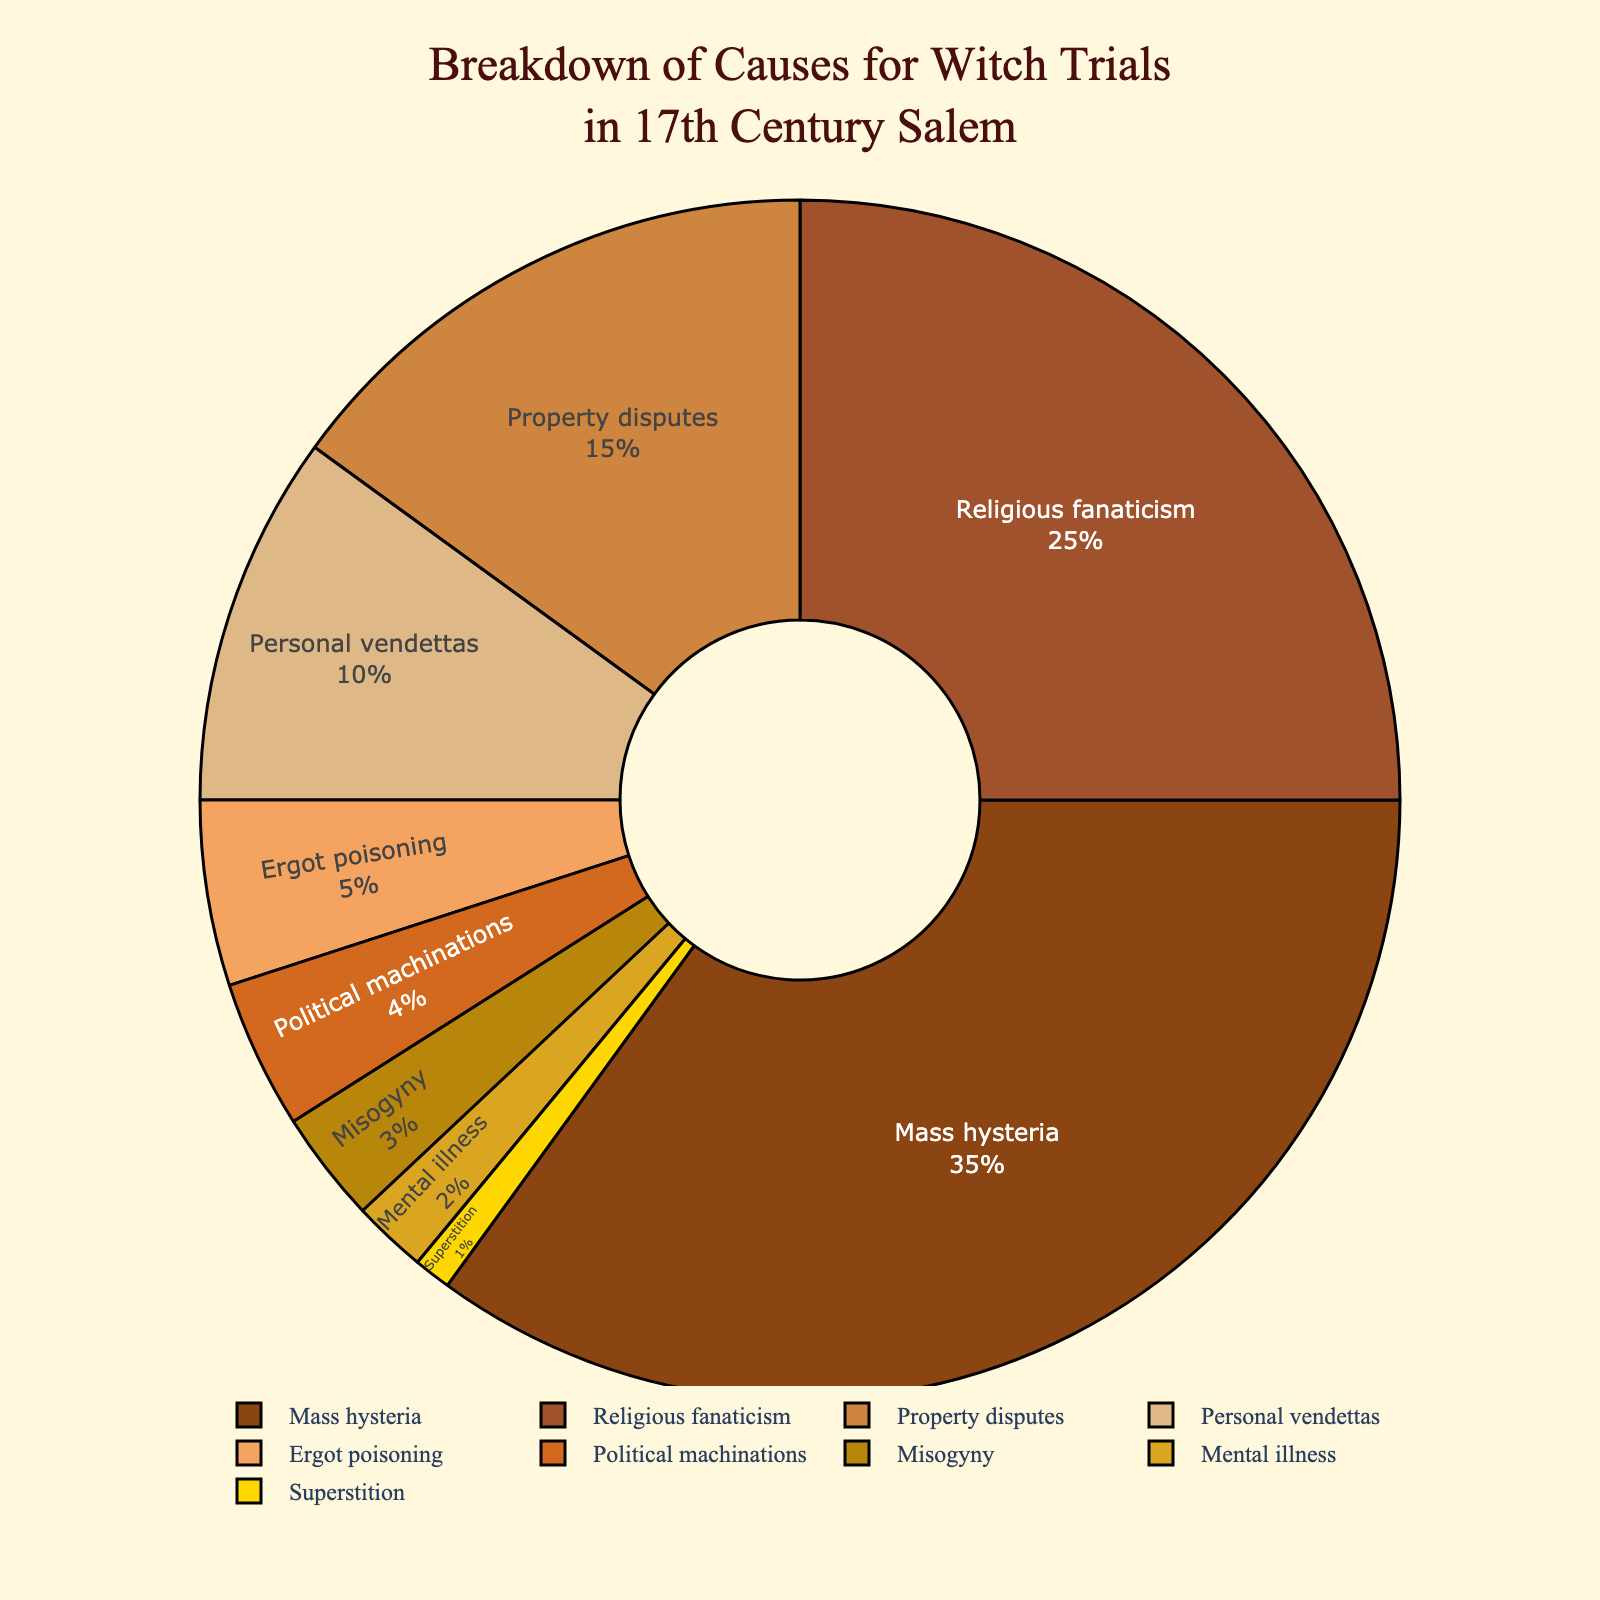Which cause has the highest percentage? To determine the cause with the highest percentage, look for the largest segment of the pie chart. The one labeled "Mass hysteria" covers the most space in the circle, indicating that it has the highest percentage.
Answer: Mass hysteria What is the combined percentage of Religious fanaticism and Property disputes? Add the percentages for Religious fanaticism (25%) and Property disputes (15%). The combined sum is 25 + 15 = 40.
Answer: 40% Which cause has the smallest percentage? The smallest segment in the pie chart corresponds to the cause labeled "Superstition," which has the smallest area and least percentage.
Answer: Superstition How much more in percentage is Mass hysteria compared to Ergot poisoning? Subtract the percentage of Ergot poisoning (5%) from Mass hysteria (35%). The difference is 35 - 5 = 30.
Answer: 30% What percentage of causes is represented by Political machinations, Misogyny, and Mental illness combined? Add the percentages of Political machinations (4%), Misogyny (3%), and Mental illness (2%). The combined sum is 4 + 3 + 2 = 9.
Answer: 9% Is the percentage of Personal vendettas greater than Property disputes? Compare 10% (Personal vendettas) and 15% (Property disputes). Since 10% is less than 15%, Property disputes have a greater percentage.
Answer: No What color is the segment representing Religious fanaticism? Identify the segment labeled "Religious fanaticism" and note its color, which is the second color from the list used in the plot.
Answer: Brown Which two causes have a combined percentage close to that of Mass hysteria? Looking at the percentages, Religious fanaticism (25%) and Property disputes (15%) together add up to 25 + 15 = 40, which is close to Mass hysteria (35%).
Answer: Religious fanaticism and Property disputes What's the percentage difference between the cause with the highest percentage and the cause with the lowest percentage? Subtract the smallest percentage (Superstition: 1%) from the highest percentage (Mass hysteria: 35%). The difference is 35 - 1 = 34.
Answer: 34% What percentage of the causes are due to Mental illness and Superstition together? Add the percentages for Mental illness (2%) and Superstition (1%). The combined sum is 2 + 1 = 3.
Answer: 3% 